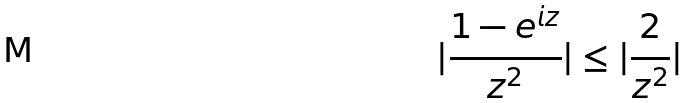<formula> <loc_0><loc_0><loc_500><loc_500>| \frac { 1 - e ^ { i z } } { z ^ { 2 } } | \leq | \frac { 2 } { z ^ { 2 } } |</formula> 